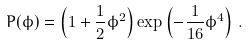<formula> <loc_0><loc_0><loc_500><loc_500>P ( \phi ) = \left ( 1 + \frac { 1 } { 2 } \phi ^ { 2 } \right ) \exp \left ( - \frac { 1 } { 1 6 } \phi ^ { 4 } \right ) \, .</formula> 